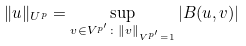Convert formula to latex. <formula><loc_0><loc_0><loc_500><loc_500>\| u \| _ { U ^ { p } } = \sup _ { v \in V ^ { p ^ { \prime } } \colon \| v \| _ { V ^ { p ^ { \prime } } = 1 } } | B ( u , v ) |</formula> 